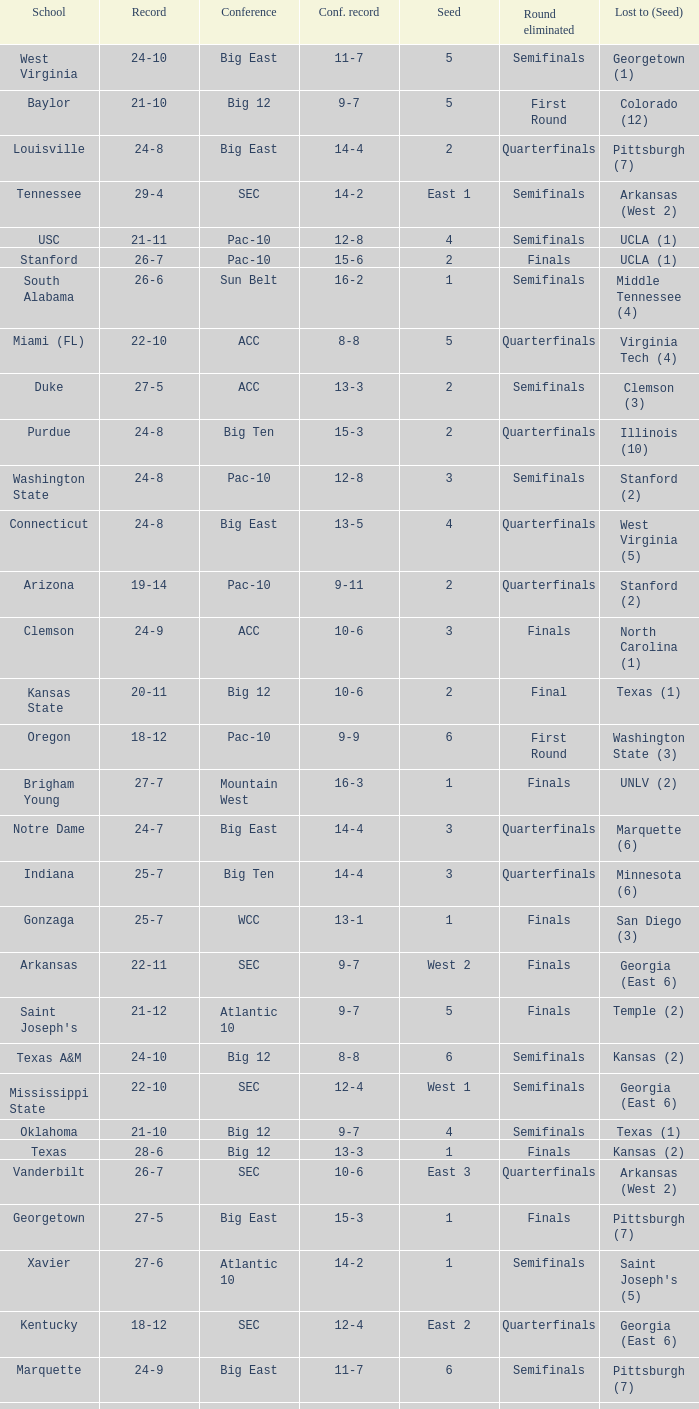Name the school where conference record is 12-6 Michigan State. 